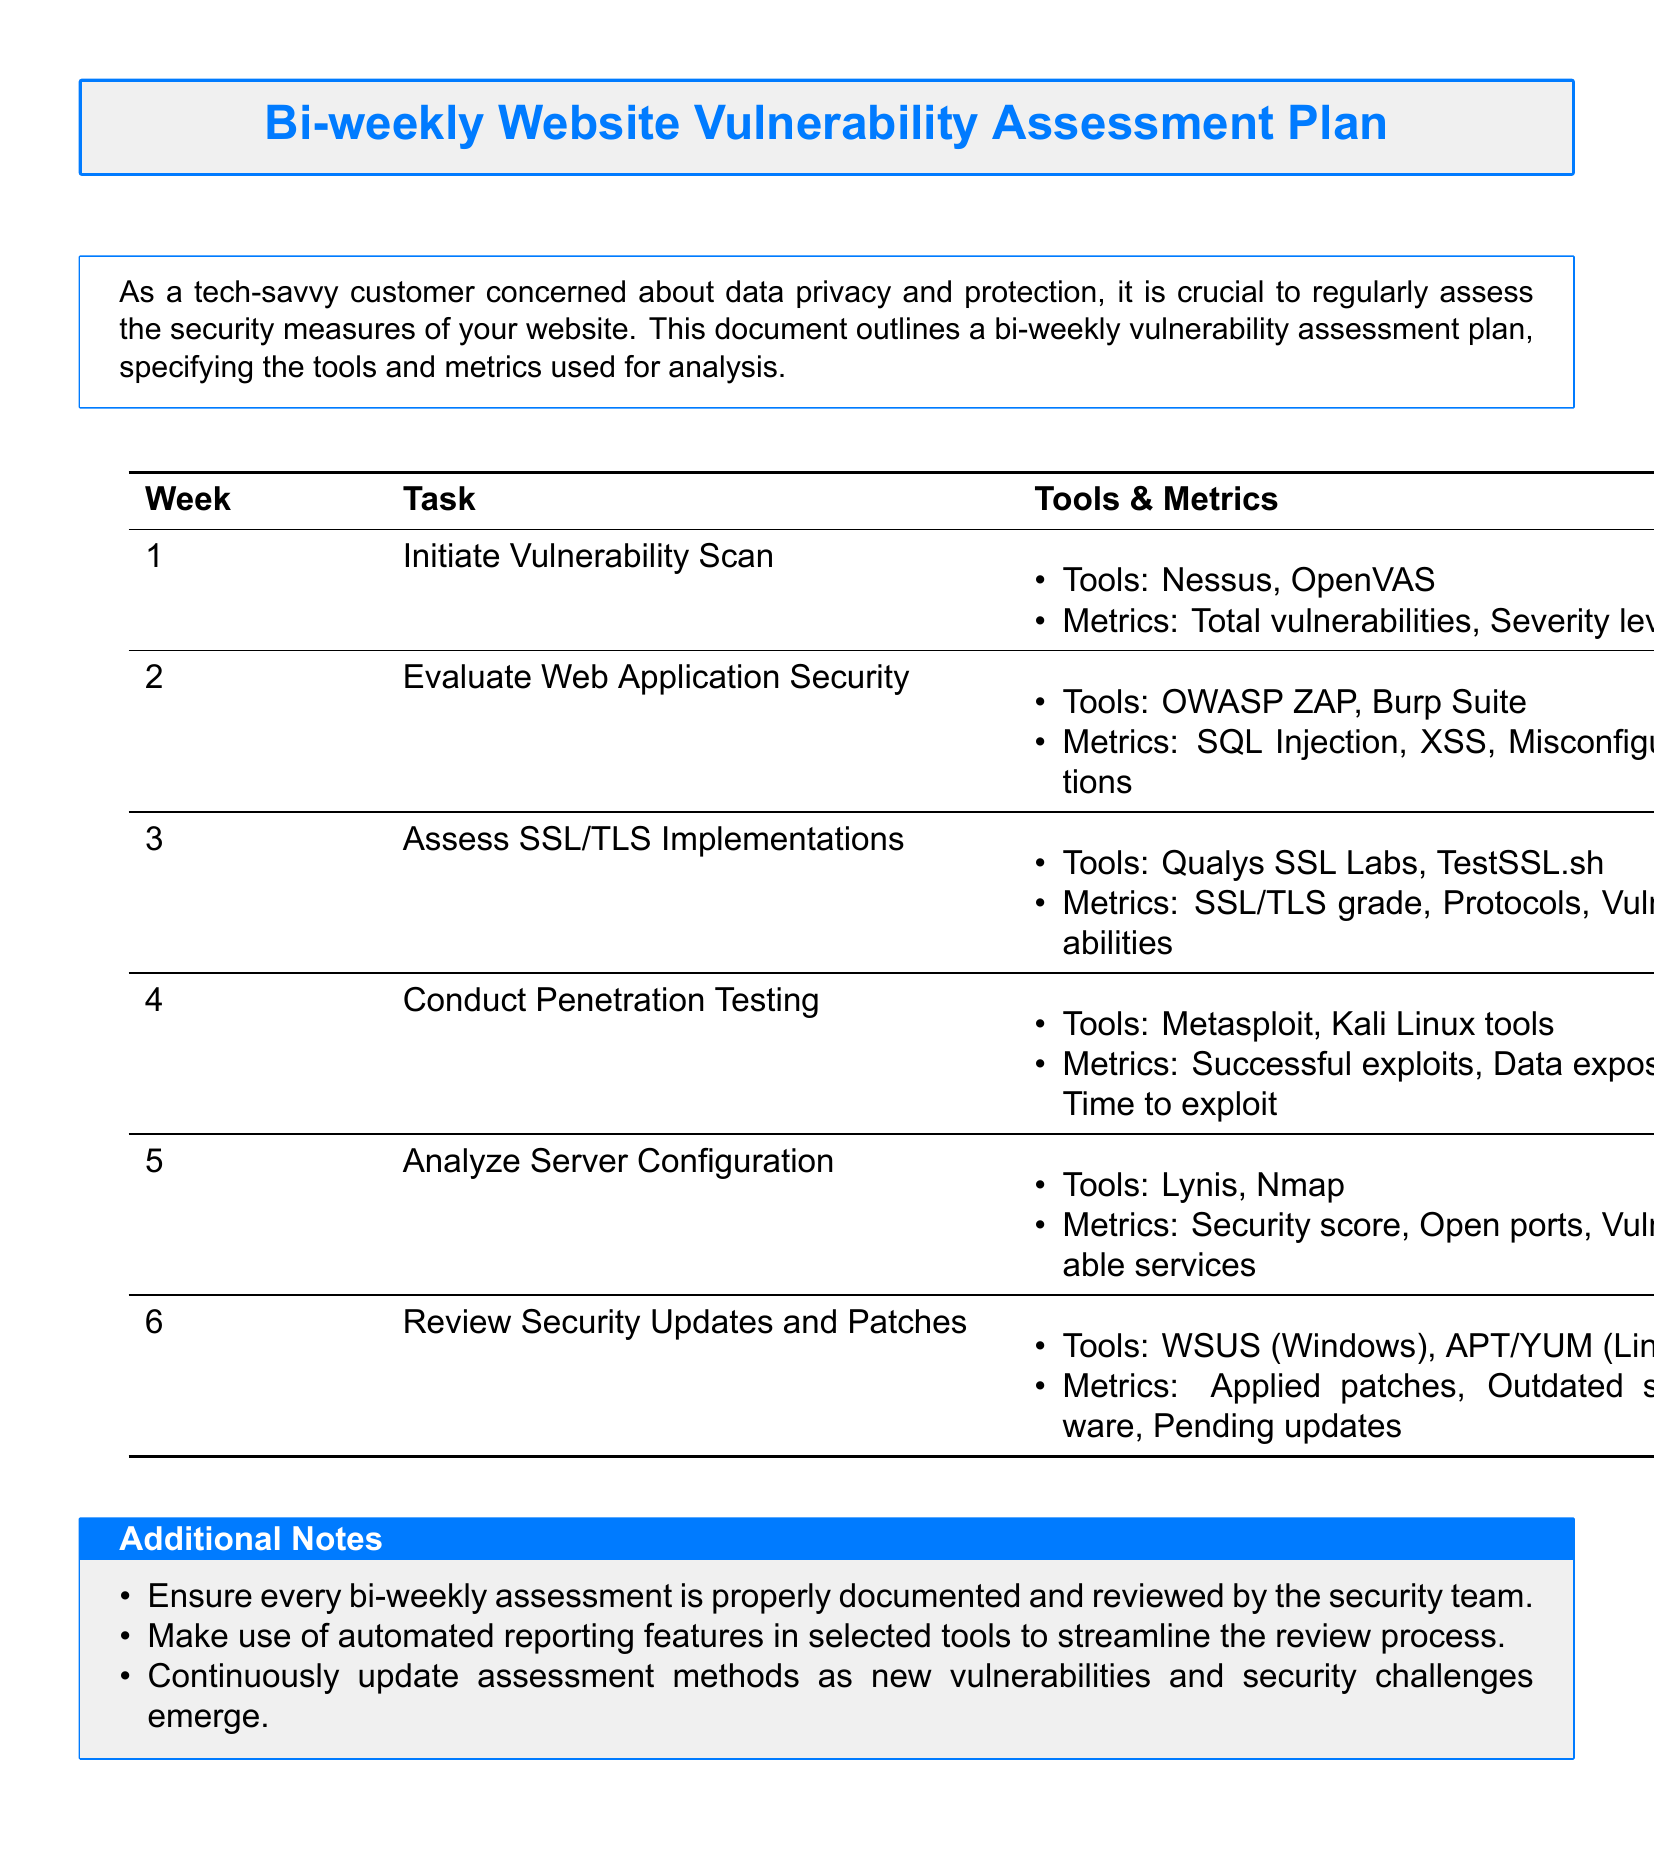What is the title of the document? The title of the document is prominently displayed at the beginning, in a tcolorbox.
Answer: Bi-weekly Website Vulnerability Assessment Plan Which tool is used for vulnerability scanning in Week 1? The document specifies the tools used for each week’s task, including the first week.
Answer: Nessus What metrics are evaluated in Week 2? The metrics for each week's task are listed clearly, focusing on the specific aspects to be assessed.
Answer: SQL Injection, XSS, Misconfigurations What is assessed in Week 3? The document outlines tasks for each week; Week 3 specifies the focus of the assessment.
Answer: SSL/TLS Implementations What is the last week dedicated to in the assessment plan? The final task in the bi-weekly assessment plan is listed at the end of the document.
Answer: Review Security Updates and Patches Which tool is used for conducting penetration testing? The document provides tools for each task, particularly identifying the tools for penetration testing.
Answer: Metasploit What is one of the metrics used in Week 5? The metrics for each week are outlined, including those assessed in Week 5.
Answer: Security score How often is the vulnerability assessment conducted according to the plan? The frequency of the assessment is described in the title and introductory part of the document.
Answer: Bi-weekly What is recommended for documenting assessments? The document suggests practices for documentation and review processes.
Answer: Properly documented and reviewed by the security team 